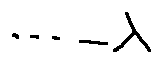Convert formula to latex. <formula><loc_0><loc_0><loc_500><loc_500>\cdots - \lambda</formula> 